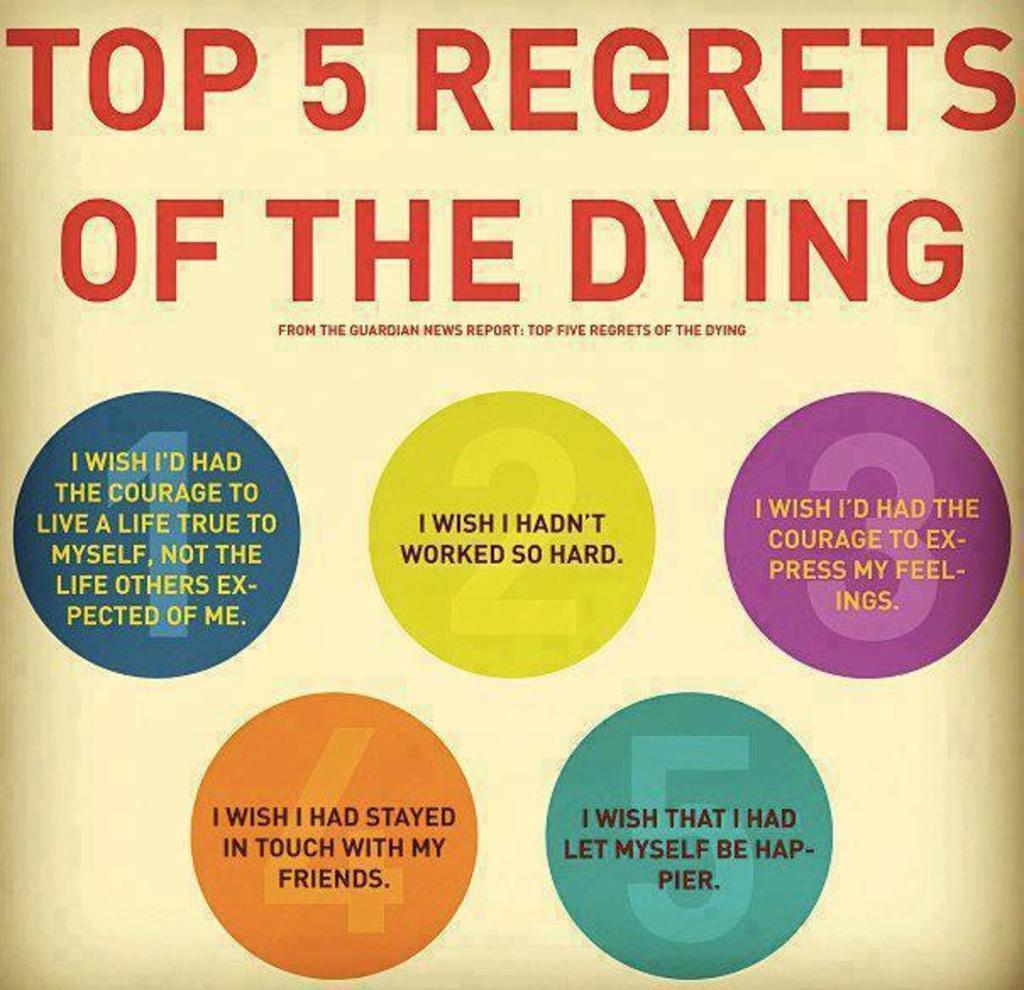Could you give a brief overview of what you see in this image? In this image there is text on the paper. 